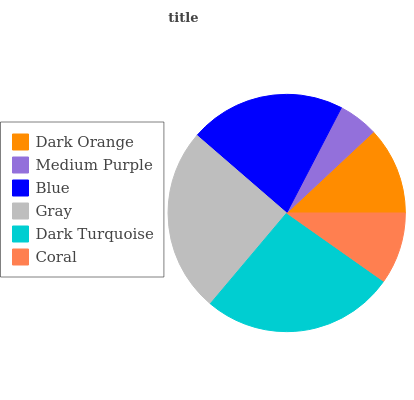Is Medium Purple the minimum?
Answer yes or no. Yes. Is Dark Turquoise the maximum?
Answer yes or no. Yes. Is Blue the minimum?
Answer yes or no. No. Is Blue the maximum?
Answer yes or no. No. Is Blue greater than Medium Purple?
Answer yes or no. Yes. Is Medium Purple less than Blue?
Answer yes or no. Yes. Is Medium Purple greater than Blue?
Answer yes or no. No. Is Blue less than Medium Purple?
Answer yes or no. No. Is Blue the high median?
Answer yes or no. Yes. Is Dark Orange the low median?
Answer yes or no. Yes. Is Coral the high median?
Answer yes or no. No. Is Blue the low median?
Answer yes or no. No. 